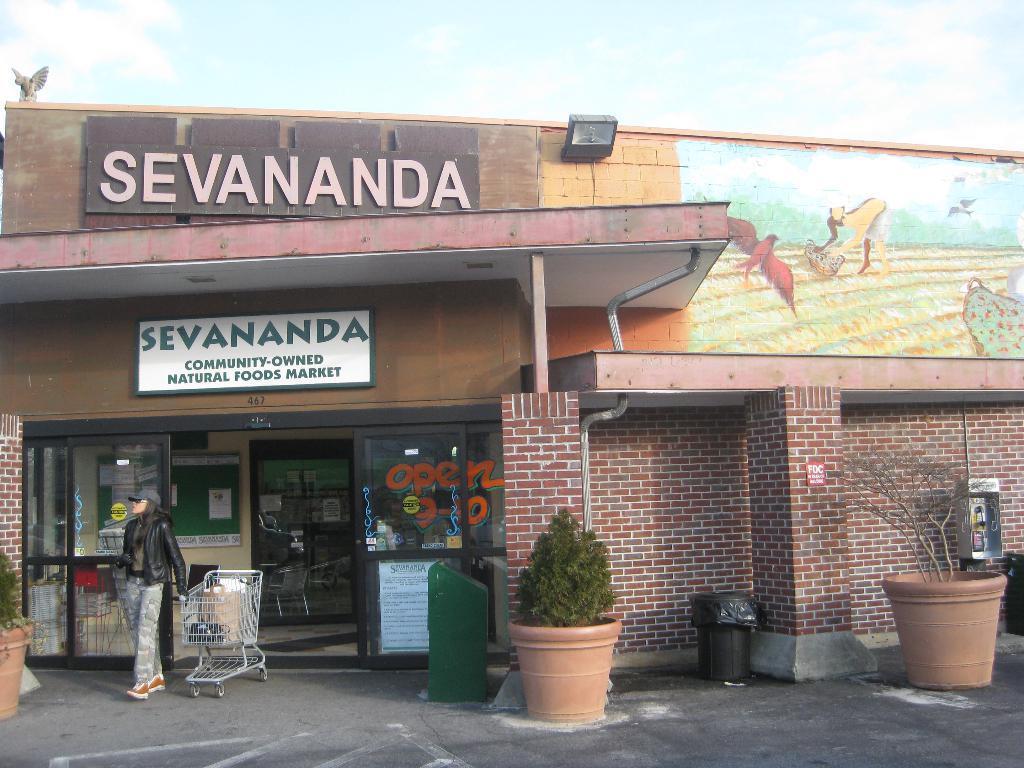Describe this image in one or two sentences. In this image a woman wearing a black jacket is holding a trolley. There are few pots having plants are on the floor having a dustbin on it. Behind there is a shop having a name board attached to the wall. A lamp is attached to the wall. There are few pictures painted on the wall. Top of image there is sky. 